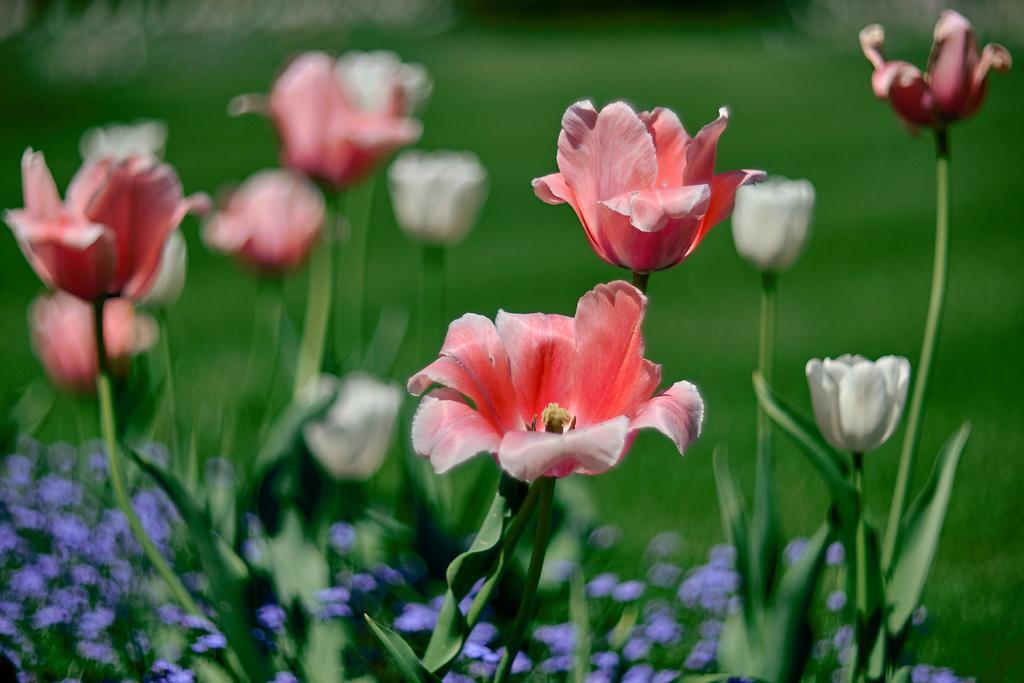Can you describe this image briefly? In this image in the foreground there are some plants and flowers, in the background there is grass. 